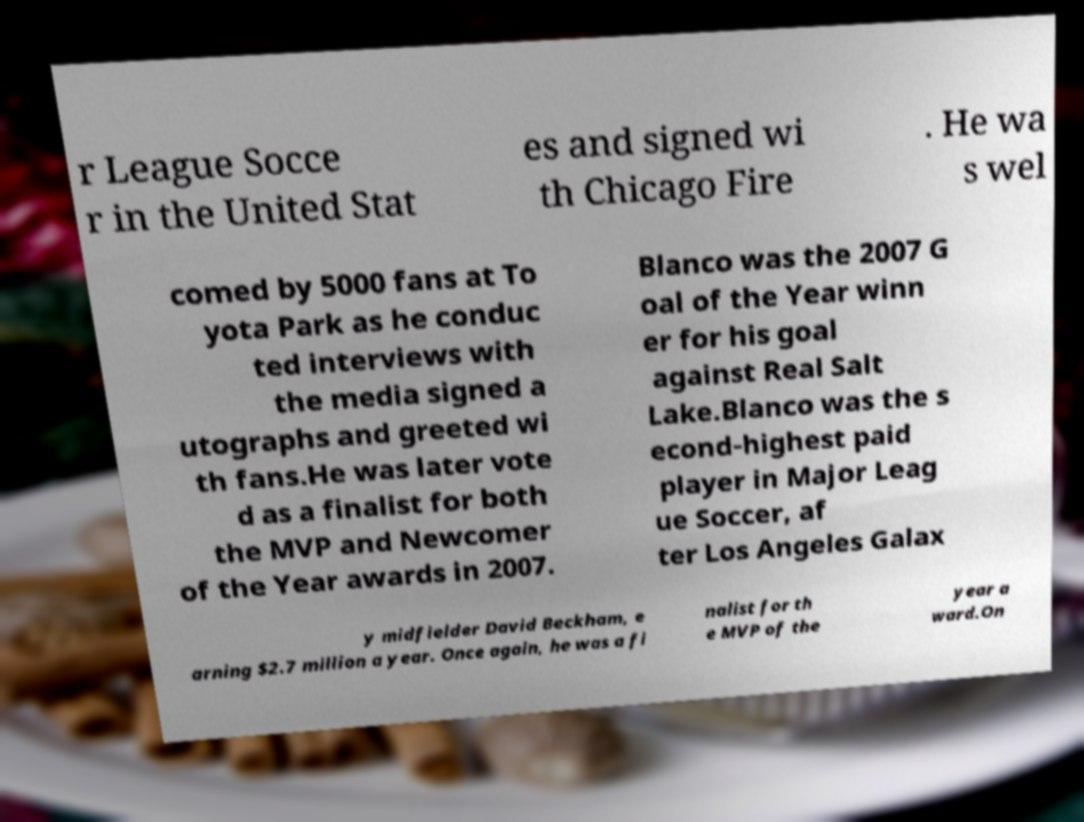Please read and relay the text visible in this image. What does it say? r League Socce r in the United Stat es and signed wi th Chicago Fire . He wa s wel comed by 5000 fans at To yota Park as he conduc ted interviews with the media signed a utographs and greeted wi th fans.He was later vote d as a finalist for both the MVP and Newcomer of the Year awards in 2007. Blanco was the 2007 G oal of the Year winn er for his goal against Real Salt Lake.Blanco was the s econd-highest paid player in Major Leag ue Soccer, af ter Los Angeles Galax y midfielder David Beckham, e arning $2.7 million a year. Once again, he was a fi nalist for th e MVP of the year a ward.On 